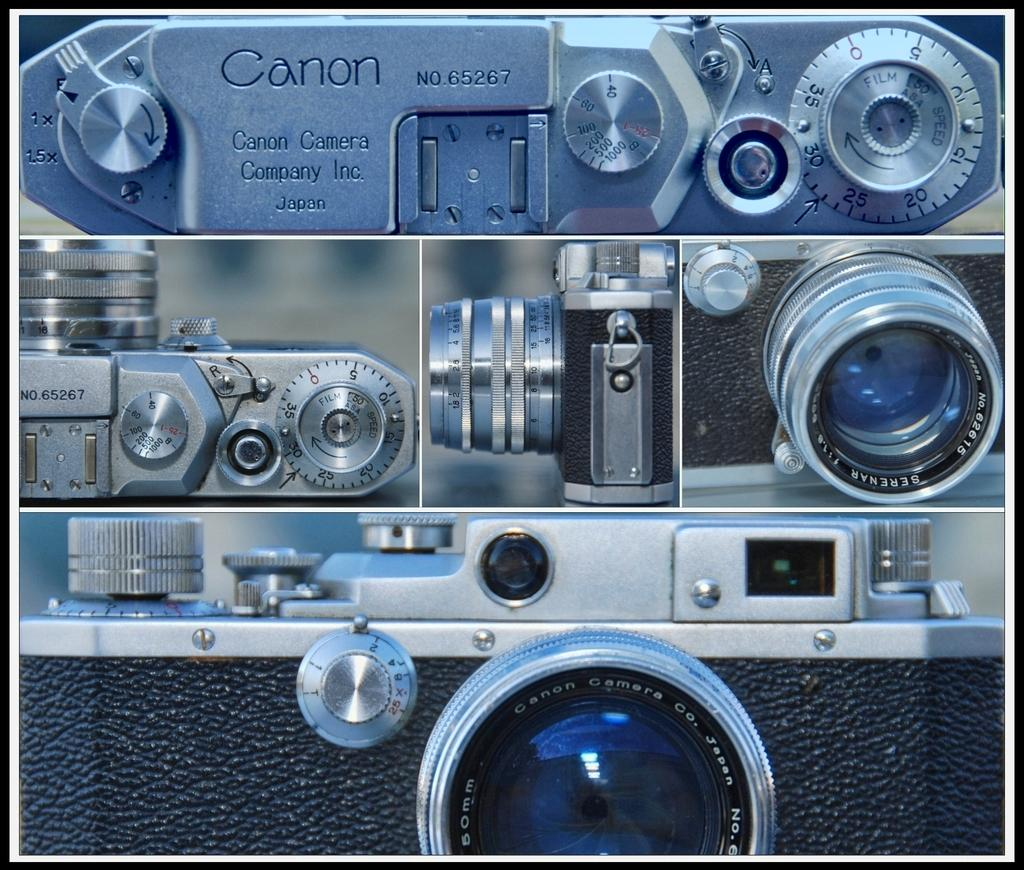What type of camera is in the image? There is a Canon camera in the image. What feature of the camera is mentioned in the facts? The camera has different lenses. What grade does the police officer give to the camera in the image? There is no police officer or grade mentioned in the image or the provided facts. 